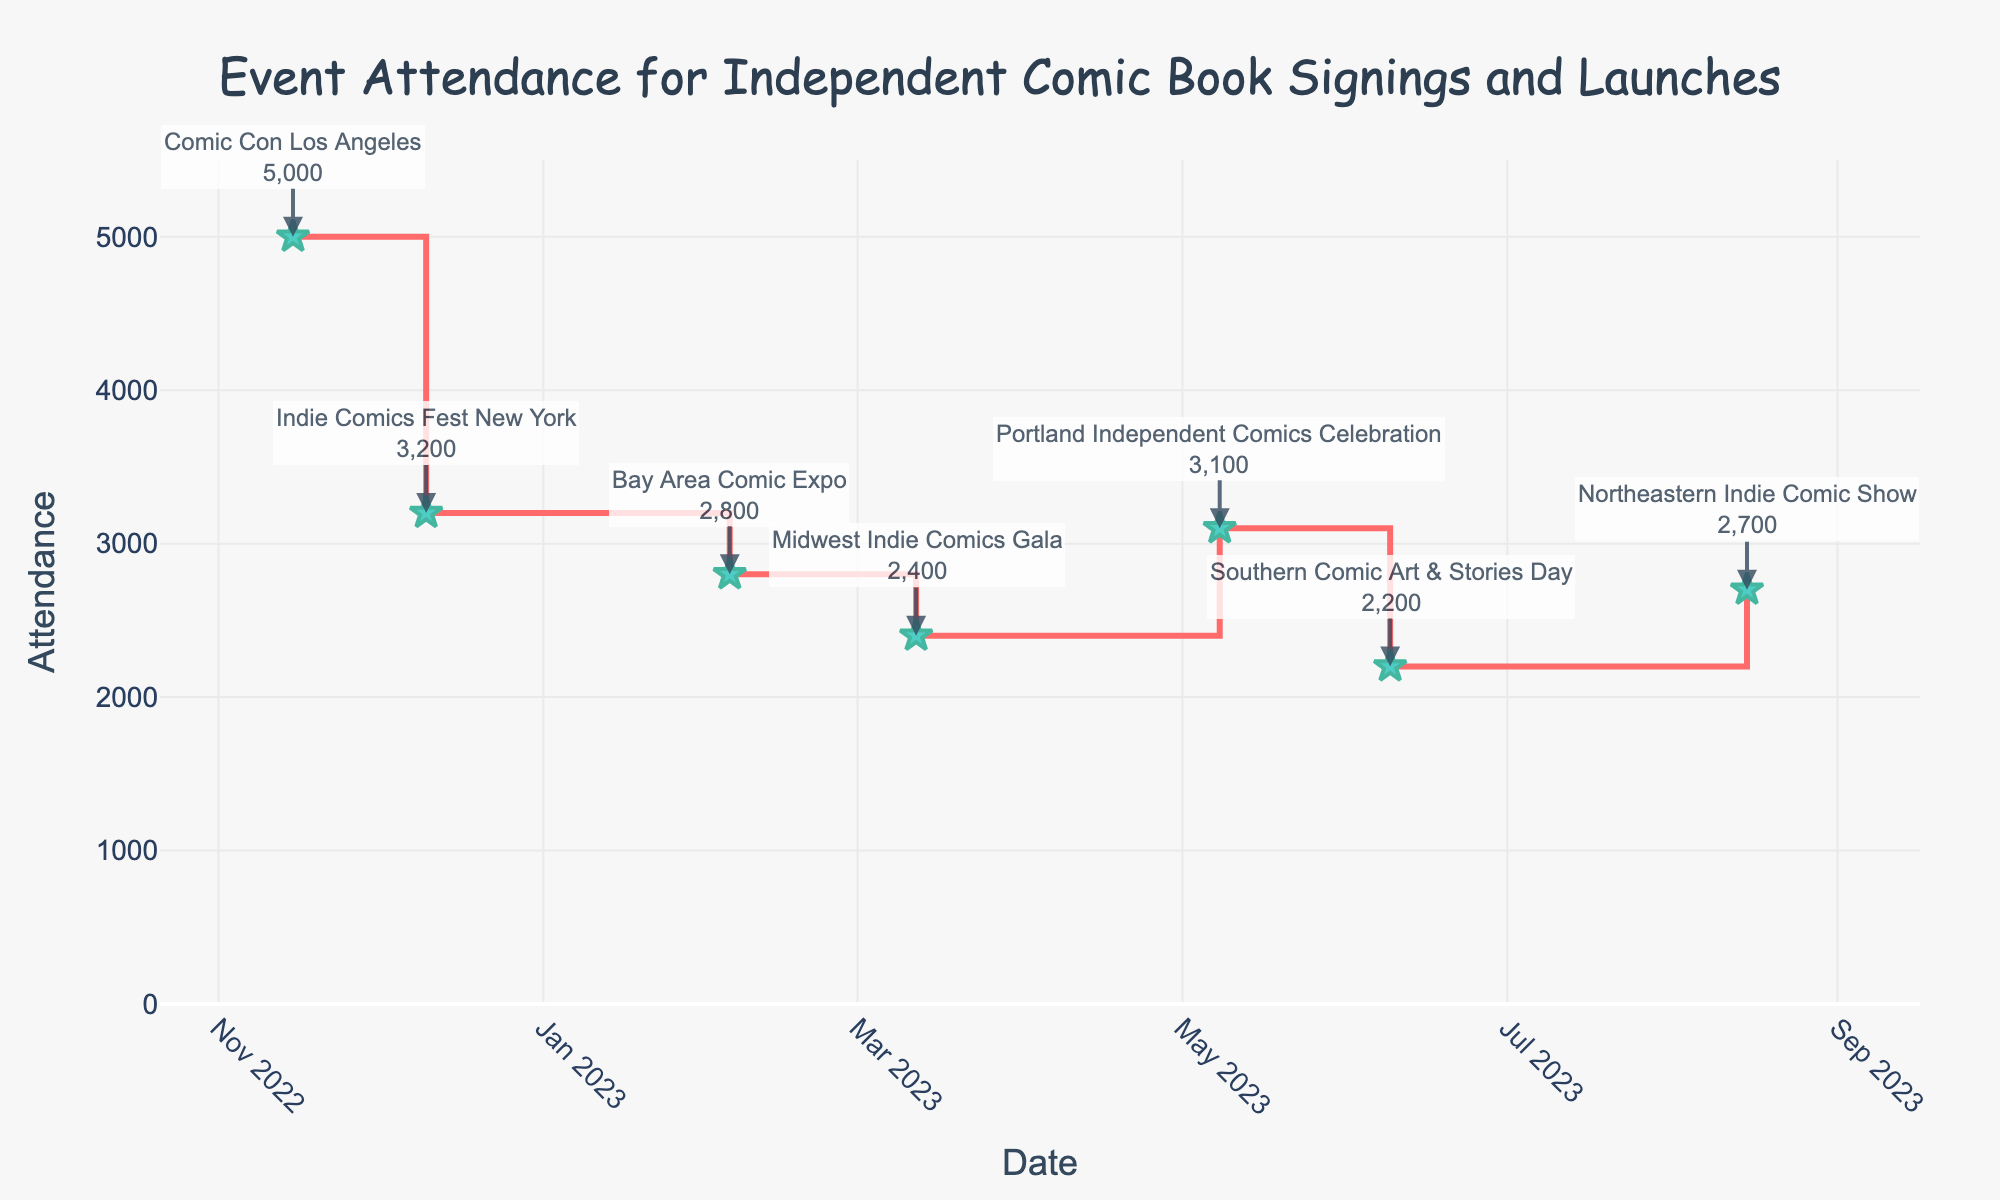What is the title of the figure? The title of the figure is given at the top, it says "Event Attendance for Independent Comic Book Signings and Launches."
Answer: Event Attendance for Independent Comic Book Signings and Launches How many events are shown in the figure? There are data points marked by star symbols on the plot, each representing an event. Counting these stars, there are seven events in total.
Answer: 7 Which event had the highest attendance? The data points marked by stars correspond to attendance figures on the y-axis. The highest point is labeled "Comic Con Los Angeles," with an attendance of 5000.
Answer: Comic Con Los Angeles What was the average attendance for these events? Summing the attendances: 5000 + 3200 + 2800 + 2400 + 3100 + 2200 + 2700 equals 21400. Dividing by the number of events (7) gives the average attendance: 21400 / 7 = 3057.14
Answer: 3057 Which month had the highest attendance for a single event? Checking the months corresponding to the highest data points, November had the highest attendance with the Comic Con Los Angeles event.
Answer: November What is the attendance difference between the Indie Comics Fest New York and Bay Area Comic Expo? The attendance for Indie Comics Fest New York was 3200 and for Bay Area Comic Expo was 2800. The difference is 3200 - 2800 = 400.
Answer: 400 Which event had the lowest attendance, and what was the figure? The data point with the smallest y-value represents the Southern Comic Art & Stories Day, with an attendance of 2200.
Answer: Southern Comic Art & Stories Day, 2200 Between Midwest Indie Comics Gala and Portland Independent Comics Celebration, which had higher attendance, and by how much? Midwest Indie Comics Gala had 2400 in attendance, and Portland Independent Comics Celebration had 3100. The difference is 3100 - 2400 = 700.
Answer: Portland Independent Comics Celebration, 700 By how much did the attendance change from the Northeastern Indie Comic Show to the first event of the year? The first event of the year was Bay Area Comic Expo with 2800 attendees, and Northeastern Indie Comic Show had 2700 attendees. The change is 2700 - 2800 = -100.
Answer: -100 